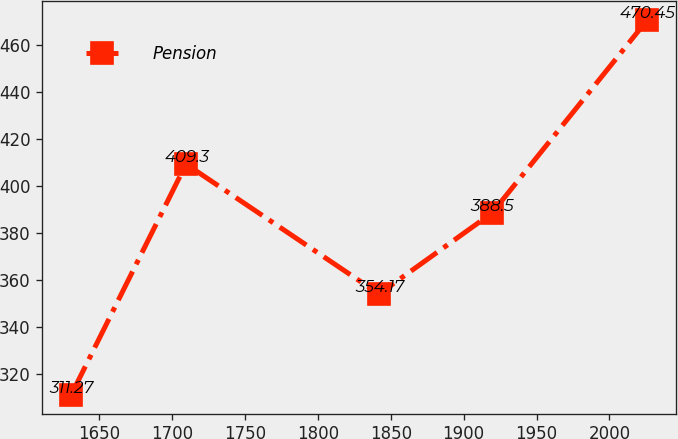Convert chart to OTSL. <chart><loc_0><loc_0><loc_500><loc_500><line_chart><ecel><fcel>Pension<nl><fcel>1630.57<fcel>311.27<nl><fcel>1709.46<fcel>409.3<nl><fcel>1841.88<fcel>354.17<nl><fcel>1919.38<fcel>388.5<nl><fcel>2026<fcel>470.45<nl></chart> 